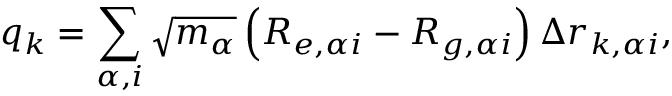<formula> <loc_0><loc_0><loc_500><loc_500>q _ { k } = \sum _ { \alpha , i } \sqrt { m _ { \alpha } } \left ( R _ { e , \alpha i } - R _ { g , \alpha i } \right ) \Delta r _ { k , \alpha i } ,</formula> 